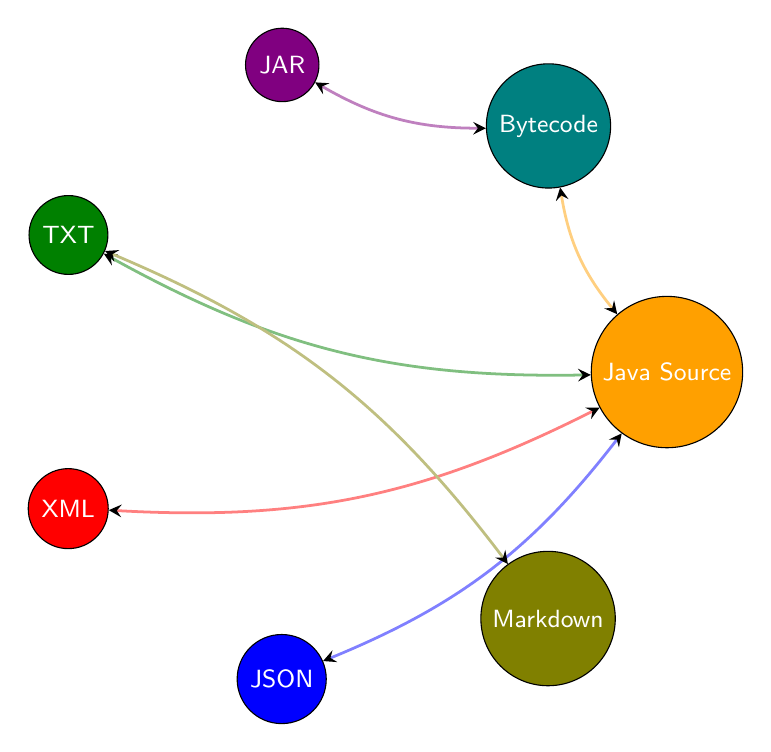What nodes are present in the diagram? The diagram includes the following nodes: Java Source Code, Java Bytecode, Java Archive, Text File, XML File, JSON File, and Markdown File. This can be identified by simply observing the labeled circles in the diagram.
Answer: Java Source Code, Java Bytecode, Java Archive, Text File, XML File, JSON File, Markdown File How many edges are in the diagram? By counting the lines connecting the nodes, we can see that there are a total of 12 edges or connections in the diagram. Each connection represents an interdependency between two file formats.
Answer: 12 Which node connects with both Java Source Code and Bytecode? Observing the edges, we can see that the Java Bytecode has connections to both the Java Source Code and Java Archive nodes, forming a direct relationship.
Answer: Java Archive What is the relationship between Java Source Code and Text File? The edges between Java Source Code and Text File can be seen clearly, showing a bidirectional connection that indicates they are interdependent formats.
Answer: Interdependent Which file format is exclusively related to Markdown in the diagram? Looking at the connecting edges, Markdown File only has an interdependency relationship with the Text File and no other files, indicating exclusivity in relationships with these two formats.
Answer: Text File How many different types of file formats are dependent on Java Source Code? By analyzing the edges originating from the Java Source Code node, we see it connects to five different file formats: Bytecode, JAR, XML, JSON, and Text File, hence five formats depend on it.
Answer: Five Which type of file can be generated directly from the Java Bytecode? The edge between Java Bytecode and Java Archive indicates that a .jar file can be directly created from .class files (Java Bytecode), denoting a clear generation relationship in the diagram.
Answer: Java Archive Can you name a file format that has both an incoming and outgoing relationship with Java Source Code? Examining the connections from the Java Source Code node, we can see that both XML File and JSON File have edges leading to and from Java Source Code, indicating they share bidirectional relationships.
Answer: XML File, JSON File What type of dependency is represented between Text File and Markdown File? The edges reveal a strong bidirectional connection between the Text File and Markdown File, indicating that both formats depend on each other for their existence or usage.
Answer: Bidirectional Dependency 